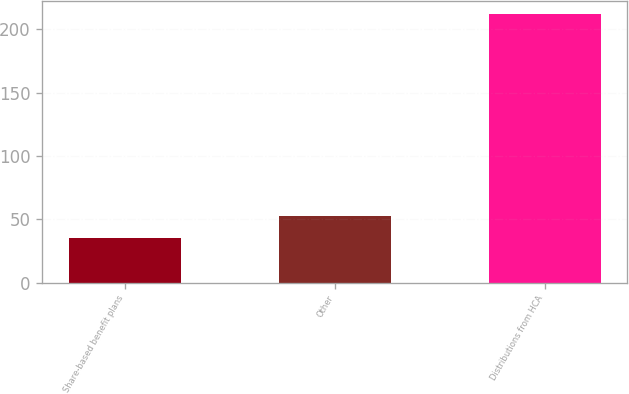Convert chart to OTSL. <chart><loc_0><loc_0><loc_500><loc_500><bar_chart><fcel>Share-based benefit plans<fcel>Other<fcel>Distributions from HCA<nl><fcel>35<fcel>52.7<fcel>212<nl></chart> 